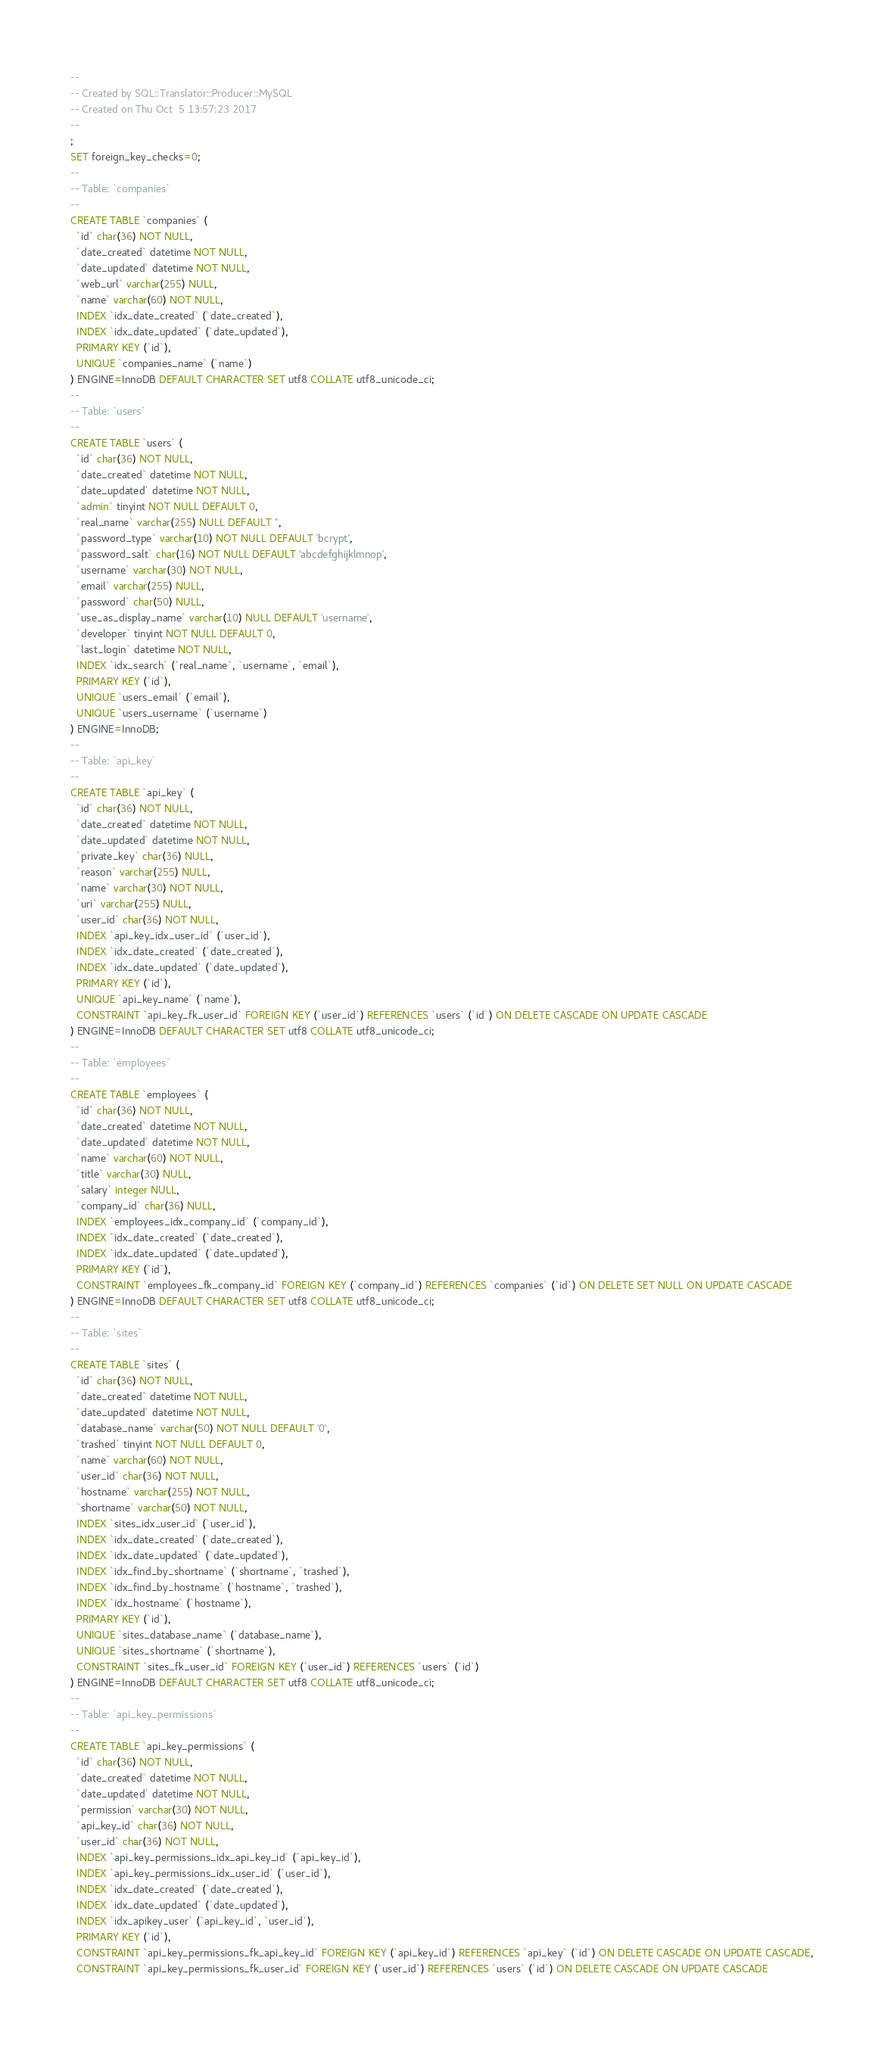Convert code to text. <code><loc_0><loc_0><loc_500><loc_500><_SQL_>-- 
-- Created by SQL::Translator::Producer::MySQL
-- Created on Thu Oct  5 13:57:23 2017
-- 
;
SET foreign_key_checks=0;
--
-- Table: `companies`
--
CREATE TABLE `companies` (
  `id` char(36) NOT NULL,
  `date_created` datetime NOT NULL,
  `date_updated` datetime NOT NULL,
  `web_url` varchar(255) NULL,
  `name` varchar(60) NOT NULL,
  INDEX `idx_date_created` (`date_created`),
  INDEX `idx_date_updated` (`date_updated`),
  PRIMARY KEY (`id`),
  UNIQUE `companies_name` (`name`)
) ENGINE=InnoDB DEFAULT CHARACTER SET utf8 COLLATE utf8_unicode_ci;
--
-- Table: `users`
--
CREATE TABLE `users` (
  `id` char(36) NOT NULL,
  `date_created` datetime NOT NULL,
  `date_updated` datetime NOT NULL,
  `admin` tinyint NOT NULL DEFAULT 0,
  `real_name` varchar(255) NULL DEFAULT '',
  `password_type` varchar(10) NOT NULL DEFAULT 'bcrypt',
  `password_salt` char(16) NOT NULL DEFAULT 'abcdefghijklmnop',
  `username` varchar(30) NOT NULL,
  `email` varchar(255) NULL,
  `password` char(50) NULL,
  `use_as_display_name` varchar(10) NULL DEFAULT 'username',
  `developer` tinyint NOT NULL DEFAULT 0,
  `last_login` datetime NOT NULL,
  INDEX `idx_search` (`real_name`, `username`, `email`),
  PRIMARY KEY (`id`),
  UNIQUE `users_email` (`email`),
  UNIQUE `users_username` (`username`)
) ENGINE=InnoDB;
--
-- Table: `api_key`
--
CREATE TABLE `api_key` (
  `id` char(36) NOT NULL,
  `date_created` datetime NOT NULL,
  `date_updated` datetime NOT NULL,
  `private_key` char(36) NULL,
  `reason` varchar(255) NULL,
  `name` varchar(30) NOT NULL,
  `uri` varchar(255) NULL,
  `user_id` char(36) NOT NULL,
  INDEX `api_key_idx_user_id` (`user_id`),
  INDEX `idx_date_created` (`date_created`),
  INDEX `idx_date_updated` (`date_updated`),
  PRIMARY KEY (`id`),
  UNIQUE `api_key_name` (`name`),
  CONSTRAINT `api_key_fk_user_id` FOREIGN KEY (`user_id`) REFERENCES `users` (`id`) ON DELETE CASCADE ON UPDATE CASCADE
) ENGINE=InnoDB DEFAULT CHARACTER SET utf8 COLLATE utf8_unicode_ci;
--
-- Table: `employees`
--
CREATE TABLE `employees` (
  `id` char(36) NOT NULL,
  `date_created` datetime NOT NULL,
  `date_updated` datetime NOT NULL,
  `name` varchar(60) NOT NULL,
  `title` varchar(30) NULL,
  `salary` integer NULL,
  `company_id` char(36) NULL,
  INDEX `employees_idx_company_id` (`company_id`),
  INDEX `idx_date_created` (`date_created`),
  INDEX `idx_date_updated` (`date_updated`),
  PRIMARY KEY (`id`),
  CONSTRAINT `employees_fk_company_id` FOREIGN KEY (`company_id`) REFERENCES `companies` (`id`) ON DELETE SET NULL ON UPDATE CASCADE
) ENGINE=InnoDB DEFAULT CHARACTER SET utf8 COLLATE utf8_unicode_ci;
--
-- Table: `sites`
--
CREATE TABLE `sites` (
  `id` char(36) NOT NULL,
  `date_created` datetime NOT NULL,
  `date_updated` datetime NOT NULL,
  `database_name` varchar(50) NOT NULL DEFAULT '0',
  `trashed` tinyint NOT NULL DEFAULT 0,
  `name` varchar(60) NOT NULL,
  `user_id` char(36) NOT NULL,
  `hostname` varchar(255) NOT NULL,
  `shortname` varchar(50) NOT NULL,
  INDEX `sites_idx_user_id` (`user_id`),
  INDEX `idx_date_created` (`date_created`),
  INDEX `idx_date_updated` (`date_updated`),
  INDEX `idx_find_by_shortname` (`shortname`, `trashed`),
  INDEX `idx_find_by_hostname` (`hostname`, `trashed`),
  INDEX `idx_hostname` (`hostname`),
  PRIMARY KEY (`id`),
  UNIQUE `sites_database_name` (`database_name`),
  UNIQUE `sites_shortname` (`shortname`),
  CONSTRAINT `sites_fk_user_id` FOREIGN KEY (`user_id`) REFERENCES `users` (`id`)
) ENGINE=InnoDB DEFAULT CHARACTER SET utf8 COLLATE utf8_unicode_ci;
--
-- Table: `api_key_permissions`
--
CREATE TABLE `api_key_permissions` (
  `id` char(36) NOT NULL,
  `date_created` datetime NOT NULL,
  `date_updated` datetime NOT NULL,
  `permission` varchar(30) NOT NULL,
  `api_key_id` char(36) NOT NULL,
  `user_id` char(36) NOT NULL,
  INDEX `api_key_permissions_idx_api_key_id` (`api_key_id`),
  INDEX `api_key_permissions_idx_user_id` (`user_id`),
  INDEX `idx_date_created` (`date_created`),
  INDEX `idx_date_updated` (`date_updated`),
  INDEX `idx_apikey_user` (`api_key_id`, `user_id`),
  PRIMARY KEY (`id`),
  CONSTRAINT `api_key_permissions_fk_api_key_id` FOREIGN KEY (`api_key_id`) REFERENCES `api_key` (`id`) ON DELETE CASCADE ON UPDATE CASCADE,
  CONSTRAINT `api_key_permissions_fk_user_id` FOREIGN KEY (`user_id`) REFERENCES `users` (`id`) ON DELETE CASCADE ON UPDATE CASCADE</code> 